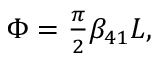Convert formula to latex. <formula><loc_0><loc_0><loc_500><loc_500>\begin{array} { r } { \Phi = \frac { \pi } { 2 } \beta _ { 4 1 } L , } \end{array}</formula> 